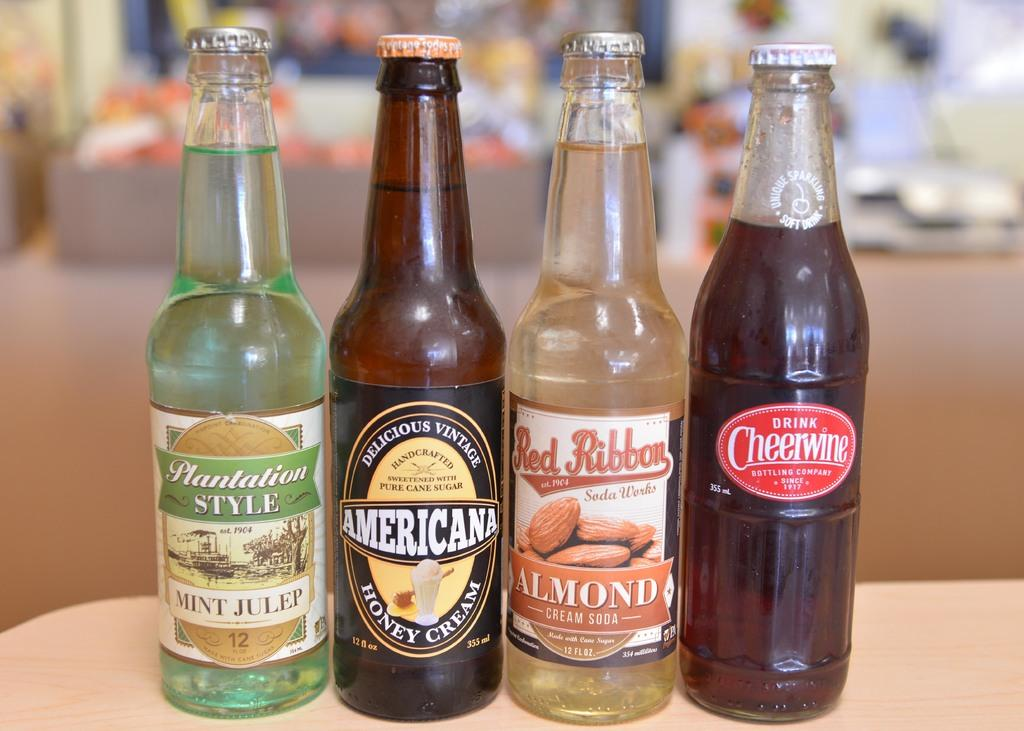How many bottles are visible in the image? There are 4 bottles in the image. What are the bottles filled with? The bottles are filled with liquids. Can you describe one of the bottles in more detail? One of the bottles has a picture of almonds on it. What type of juice is being squeezed out of the bat in the image? There is no bat or juice present in the image; it only features bottles filled with liquids. 